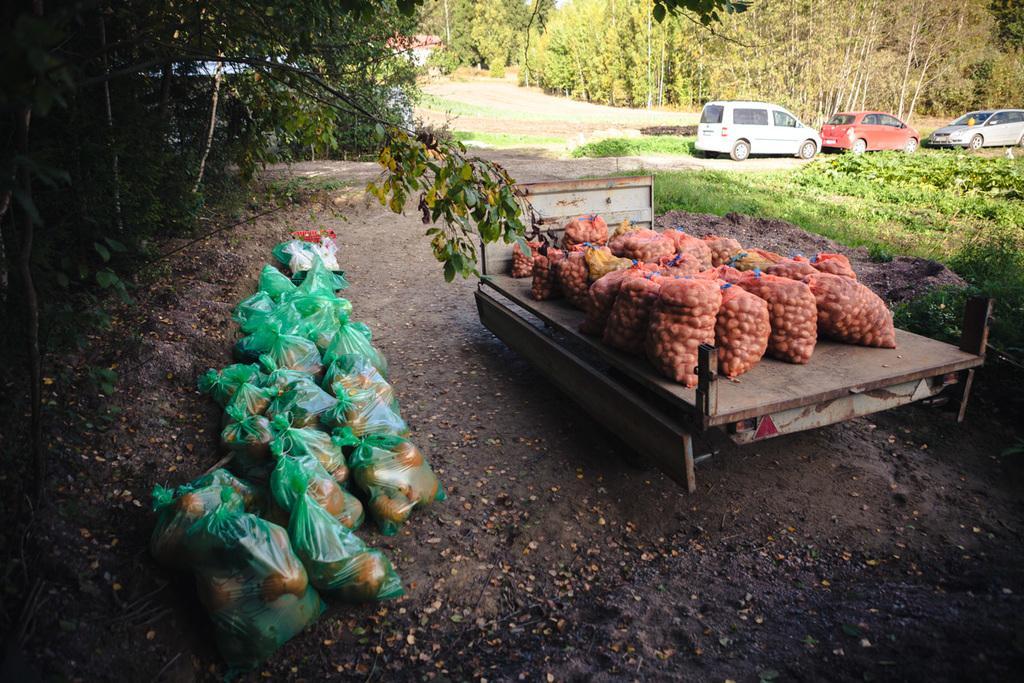Please provide a concise description of this image. In the image there are some vegetables packed and kept on a truck and on the left side there are pumpkins packed in the covers and kept on the ground. There are trees, grass and vehicles in the image. 